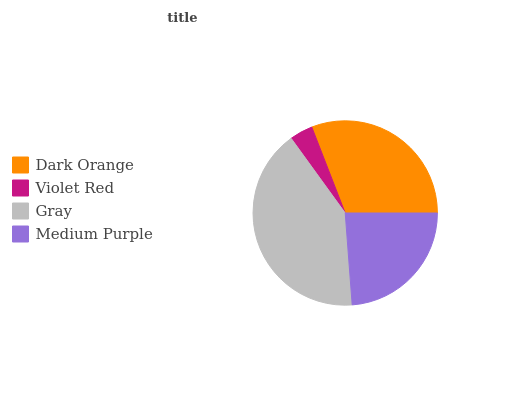Is Violet Red the minimum?
Answer yes or no. Yes. Is Gray the maximum?
Answer yes or no. Yes. Is Gray the minimum?
Answer yes or no. No. Is Violet Red the maximum?
Answer yes or no. No. Is Gray greater than Violet Red?
Answer yes or no. Yes. Is Violet Red less than Gray?
Answer yes or no. Yes. Is Violet Red greater than Gray?
Answer yes or no. No. Is Gray less than Violet Red?
Answer yes or no. No. Is Dark Orange the high median?
Answer yes or no. Yes. Is Medium Purple the low median?
Answer yes or no. Yes. Is Medium Purple the high median?
Answer yes or no. No. Is Dark Orange the low median?
Answer yes or no. No. 